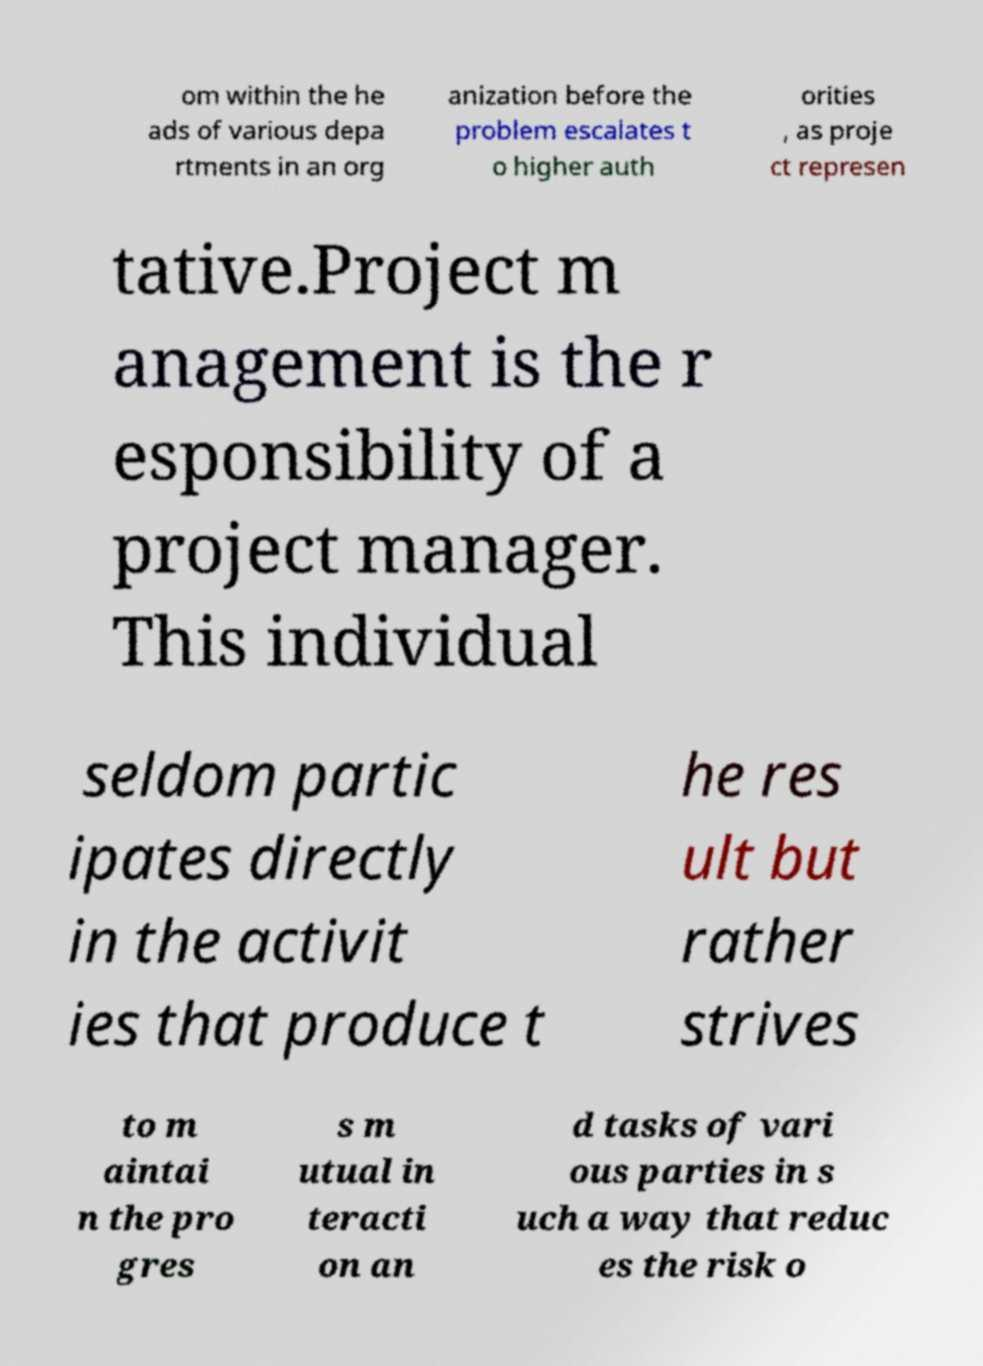For documentation purposes, I need the text within this image transcribed. Could you provide that? om within the he ads of various depa rtments in an org anization before the problem escalates t o higher auth orities , as proje ct represen tative.Project m anagement is the r esponsibility of a project manager. This individual seldom partic ipates directly in the activit ies that produce t he res ult but rather strives to m aintai n the pro gres s m utual in teracti on an d tasks of vari ous parties in s uch a way that reduc es the risk o 